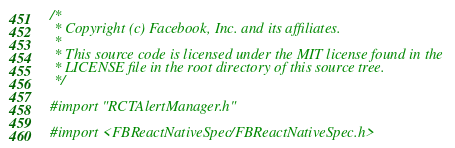<code> <loc_0><loc_0><loc_500><loc_500><_ObjectiveC_>/*
 * Copyright (c) Facebook, Inc. and its affiliates.
 *
 * This source code is licensed under the MIT license found in the
 * LICENSE file in the root directory of this source tree.
 */

#import "RCTAlertManager.h"

#import <FBReactNativeSpec/FBReactNativeSpec.h></code> 